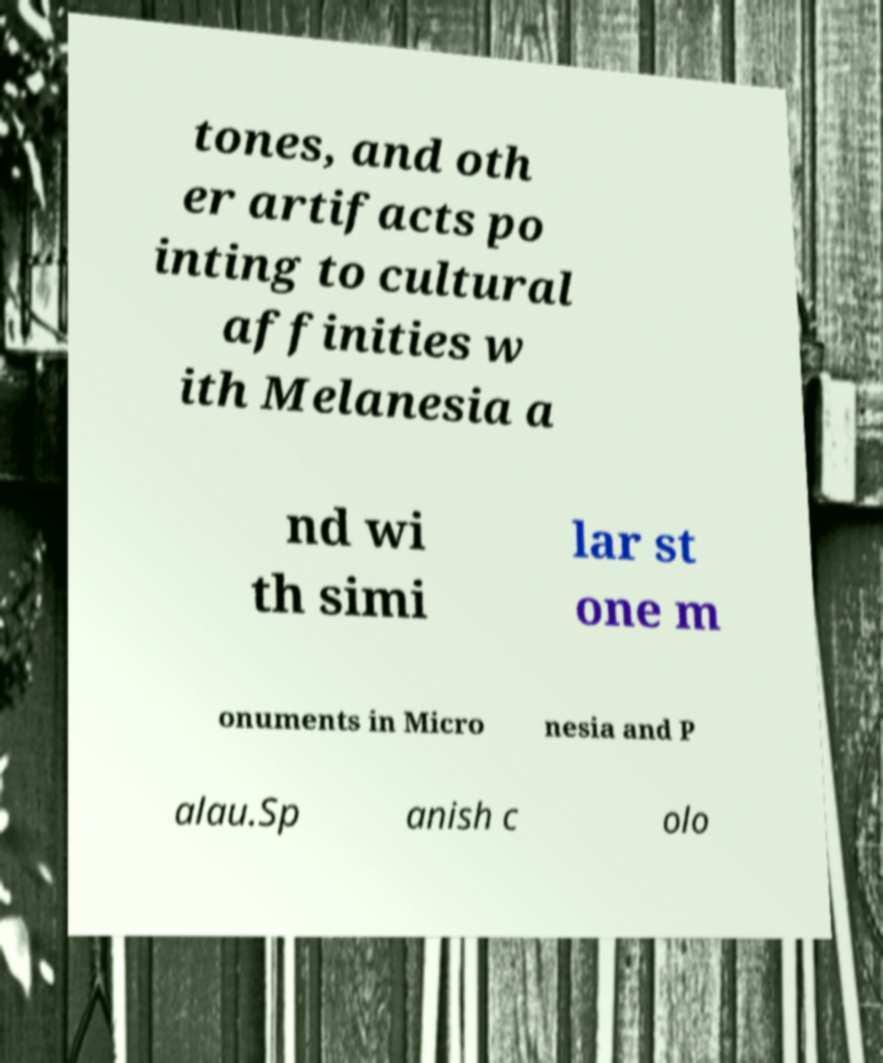Could you assist in decoding the text presented in this image and type it out clearly? tones, and oth er artifacts po inting to cultural affinities w ith Melanesia a nd wi th simi lar st one m onuments in Micro nesia and P alau.Sp anish c olo 